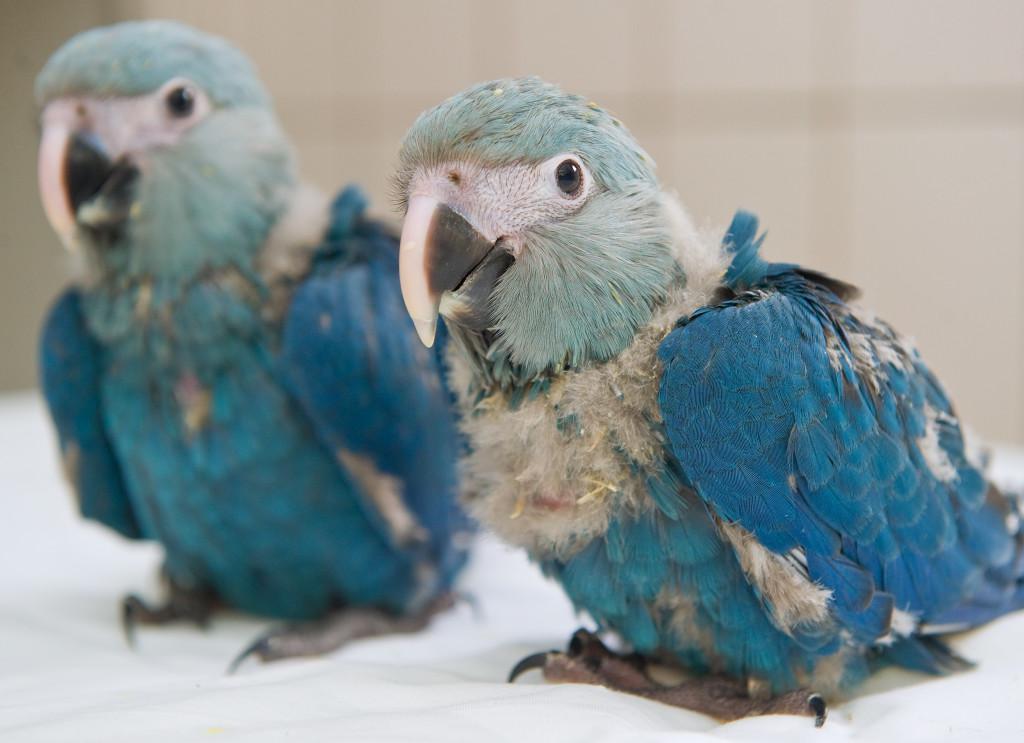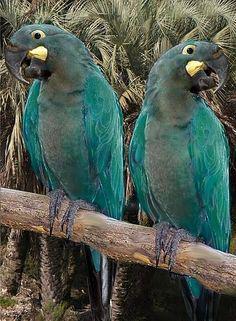The first image is the image on the left, the second image is the image on the right. Assess this claim about the two images: "There is exactly one bird in the image on the right.". Correct or not? Answer yes or no. No. 